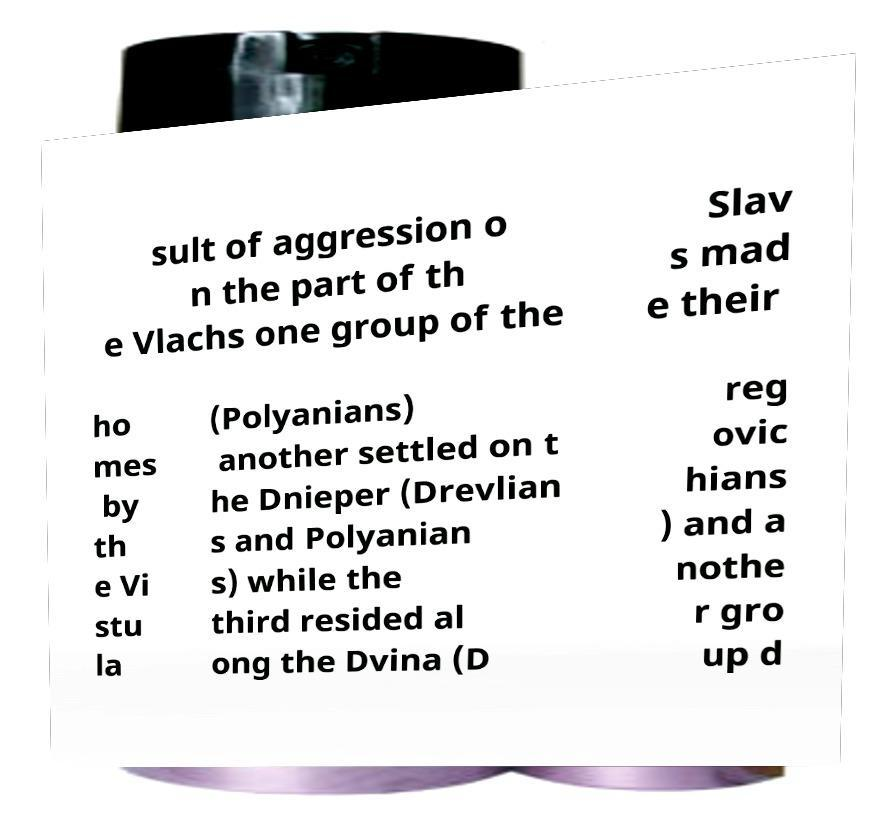For documentation purposes, I need the text within this image transcribed. Could you provide that? sult of aggression o n the part of th e Vlachs one group of the Slav s mad e their ho mes by th e Vi stu la (Polyanians) another settled on t he Dnieper (Drevlian s and Polyanian s) while the third resided al ong the Dvina (D reg ovic hians ) and a nothe r gro up d 